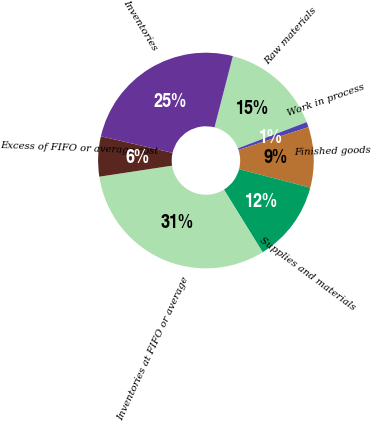Convert chart. <chart><loc_0><loc_0><loc_500><loc_500><pie_chart><fcel>Raw materials<fcel>Work in process<fcel>Finished goods<fcel>Supplies and materials<fcel>Inventories at FIFO or average<fcel>Excess of FIFO or average cost<fcel>Inventories<nl><fcel>15.19%<fcel>0.78%<fcel>9.07%<fcel>12.13%<fcel>31.41%<fcel>6.0%<fcel>25.41%<nl></chart> 